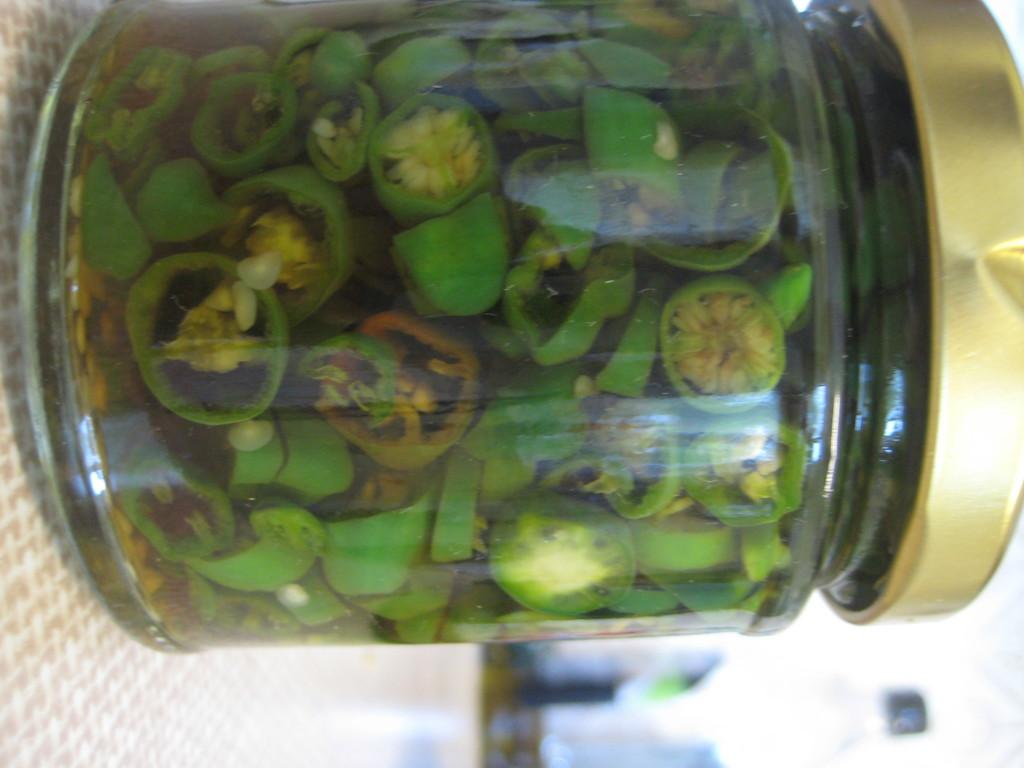What is inside the jar that is visible in the picture? There is a jar with chilies in the picture. How are the chilies in the jar prepared? The chilies are cut into pieces. What else can be seen in the background of the picture? There is a bottle in the background of the picture. What type of punishment is being given to the rat in the picture? There is no rat present in the picture, so no punishment can be observed. 